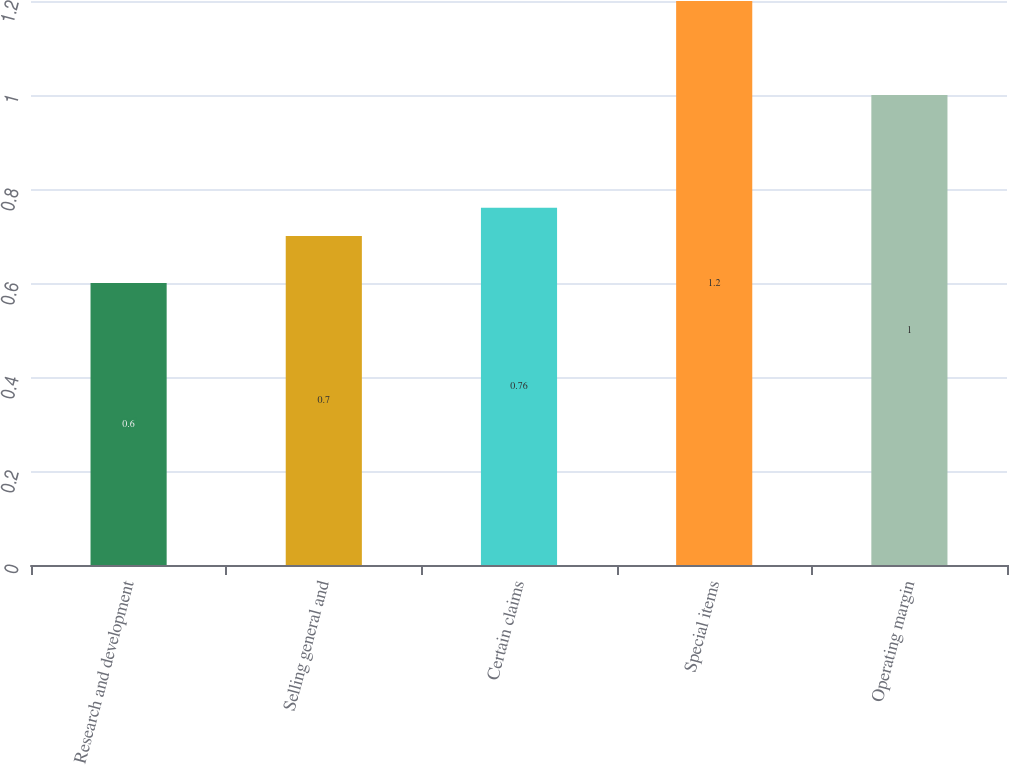<chart> <loc_0><loc_0><loc_500><loc_500><bar_chart><fcel>Research and development<fcel>Selling general and<fcel>Certain claims<fcel>Special items<fcel>Operating margin<nl><fcel>0.6<fcel>0.7<fcel>0.76<fcel>1.2<fcel>1<nl></chart> 